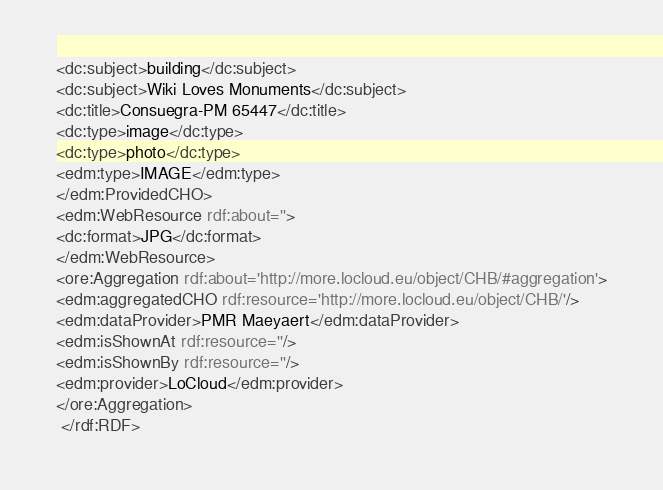Convert code to text. <code><loc_0><loc_0><loc_500><loc_500><_XML_><dc:subject>building</dc:subject>
<dc:subject>Wiki Loves Monuments</dc:subject>
<dc:title>Consuegra-PM 65447</dc:title>
<dc:type>image</dc:type>
<dc:type>photo</dc:type>
<edm:type>IMAGE</edm:type>
</edm:ProvidedCHO>
<edm:WebResource rdf:about=''>
<dc:format>JPG</dc:format>
</edm:WebResource>
<ore:Aggregation rdf:about='http://more.locloud.eu/object/CHB/#aggregation'>
<edm:aggregatedCHO rdf:resource='http://more.locloud.eu/object/CHB/'/>
<edm:dataProvider>PMR Maeyaert</edm:dataProvider>
<edm:isShownAt rdf:resource=''/>
<edm:isShownBy rdf:resource=''/>
<edm:provider>LoCloud</edm:provider>
</ore:Aggregation>
 </rdf:RDF>
</code> 